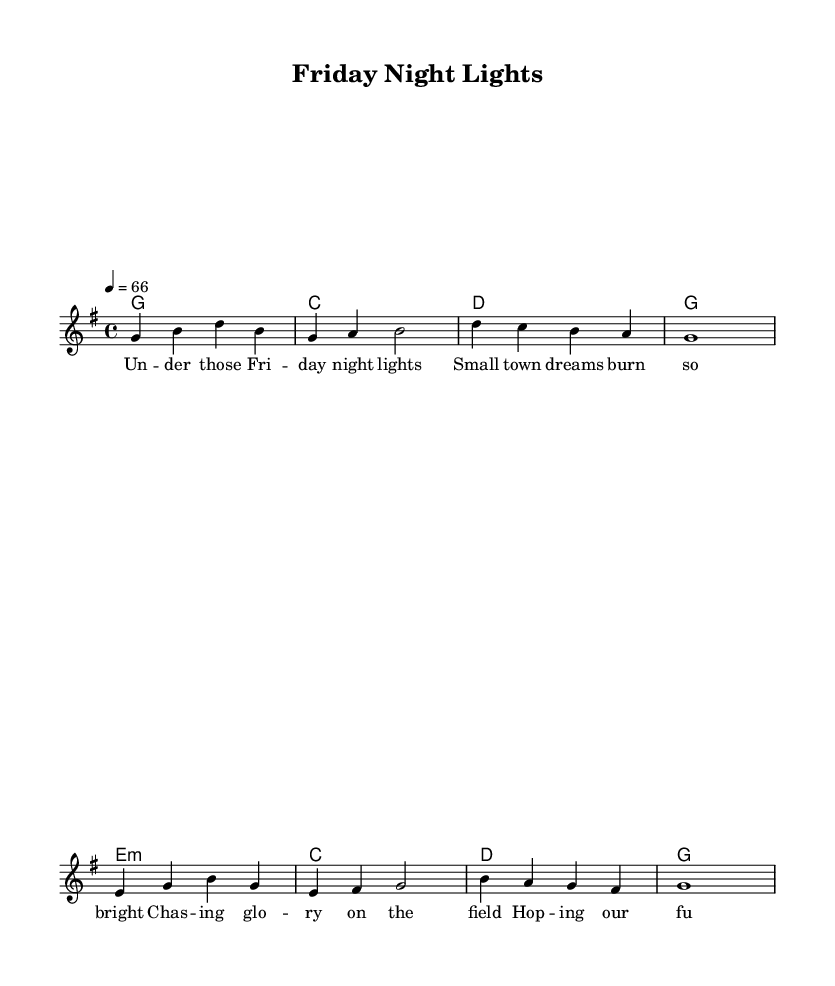What is the key signature of this music? The key signature indicates the key of G major, which contains one sharp (F#) as shown in the key signature on the left side of the staff.
Answer: G major What is the time signature of this music? The time signature is 4/4, which is indicated at the beginning of the staff. This means there are four beats in each measure and a quarter note receives one beat.
Answer: 4/4 What is the tempo marking for this piece? The tempo marking indicates a speed of 66 beats per minute, as indicated by the tempo specification at the beginning of the piece.
Answer: 66 How many measures does the melody contain? The melody consists of eight measures, as counted from the beginning to the end of the melody line, delineated by the vertical bar lines representing measure divisions.
Answer: 8 What is the main theme depicted in the lyrics of this piece? The lyrics convey the dreams of high school football players under Friday night lights, reflecting on aspirations and hopes for their futures. This thematic content is evident in the phrases discussing chasing glory and sealing futures.
Answer: Small-town football dreams Which chord follows the G major chord in the harmonies? The harmony after the G major chord is C major, which is evident in the chord progression provided below the melody line. The order of chords shows C coming after the G chord.
Answer: C 